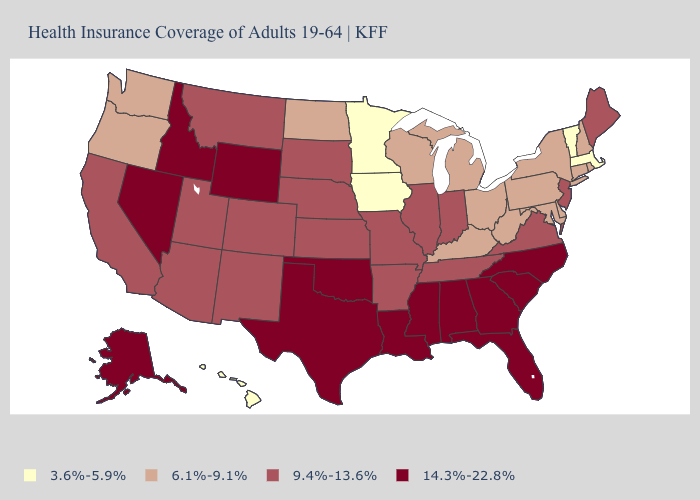What is the lowest value in the Northeast?
Concise answer only. 3.6%-5.9%. Name the states that have a value in the range 3.6%-5.9%?
Answer briefly. Hawaii, Iowa, Massachusetts, Minnesota, Vermont. Name the states that have a value in the range 6.1%-9.1%?
Answer briefly. Connecticut, Delaware, Kentucky, Maryland, Michigan, New Hampshire, New York, North Dakota, Ohio, Oregon, Pennsylvania, Rhode Island, Washington, West Virginia, Wisconsin. Is the legend a continuous bar?
Concise answer only. No. Name the states that have a value in the range 9.4%-13.6%?
Quick response, please. Arizona, Arkansas, California, Colorado, Illinois, Indiana, Kansas, Maine, Missouri, Montana, Nebraska, New Jersey, New Mexico, South Dakota, Tennessee, Utah, Virginia. What is the value of Maryland?
Concise answer only. 6.1%-9.1%. Does Georgia have a lower value than New Mexico?
Be succinct. No. What is the highest value in the USA?
Answer briefly. 14.3%-22.8%. What is the highest value in the USA?
Quick response, please. 14.3%-22.8%. Does the first symbol in the legend represent the smallest category?
Short answer required. Yes. Does Maryland have the lowest value in the South?
Quick response, please. Yes. Name the states that have a value in the range 14.3%-22.8%?
Give a very brief answer. Alabama, Alaska, Florida, Georgia, Idaho, Louisiana, Mississippi, Nevada, North Carolina, Oklahoma, South Carolina, Texas, Wyoming. What is the value of Arkansas?
Be succinct. 9.4%-13.6%. Which states have the lowest value in the USA?
Write a very short answer. Hawaii, Iowa, Massachusetts, Minnesota, Vermont. How many symbols are there in the legend?
Answer briefly. 4. 